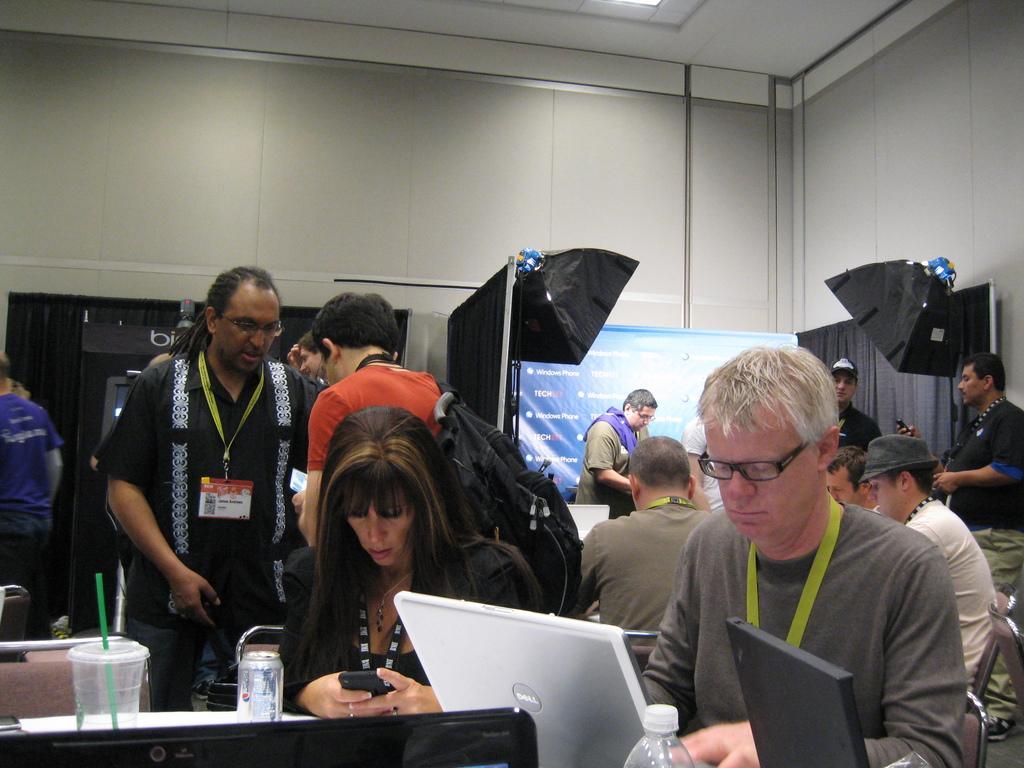How would you summarize this image in a sentence or two? In this image, we can see people and some are wearing id cards and sitting on the chairs and one of them is wearing a bag and we can see laptops, a tin, bottle and there are some other objects on the tables. In the background, there are umbrellas and we can see a banner with some text and there is a curtain and a wall. At the top, there is light. 